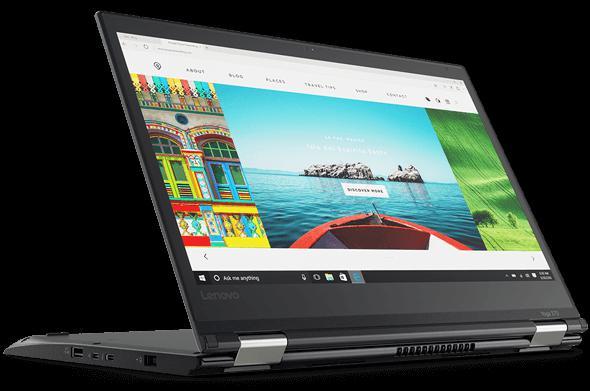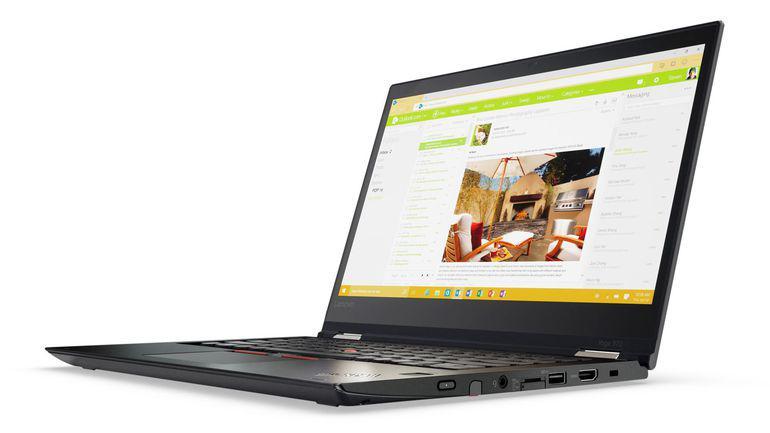The first image is the image on the left, the second image is the image on the right. For the images displayed, is the sentence "Every laptop is shown on a solid white background." factually correct? Answer yes or no. No. The first image is the image on the left, the second image is the image on the right. Assess this claim about the two images: "Each image shows an open tablet laptop sitting flat on its keyboard base, with a picture on its screen, and at least one image shows the screen reversed so the picture is on the back.". Correct or not? Answer yes or no. Yes. 